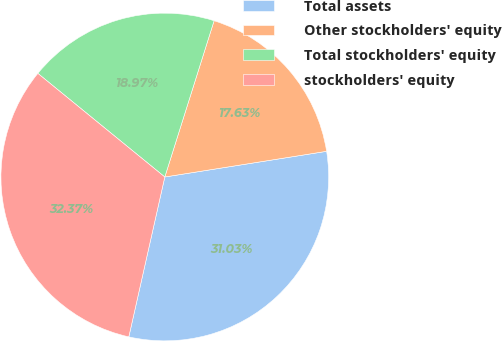<chart> <loc_0><loc_0><loc_500><loc_500><pie_chart><fcel>Total assets<fcel>Other stockholders' equity<fcel>Total stockholders' equity<fcel>stockholders' equity<nl><fcel>31.03%<fcel>17.63%<fcel>18.97%<fcel>32.37%<nl></chart> 